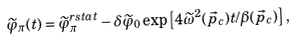Convert formula to latex. <formula><loc_0><loc_0><loc_500><loc_500>\widetilde { \varphi } _ { \pi } ( t ) = \widetilde { \varphi } _ { \pi } ^ { r { s t a t } } - \delta \widetilde { \varphi } _ { 0 } \exp \left [ 4 \widetilde { \omega } ^ { 2 } ( \vec { p } _ { c } ) t / \beta ( \vec { p } _ { c } ) \right ] ,</formula> 